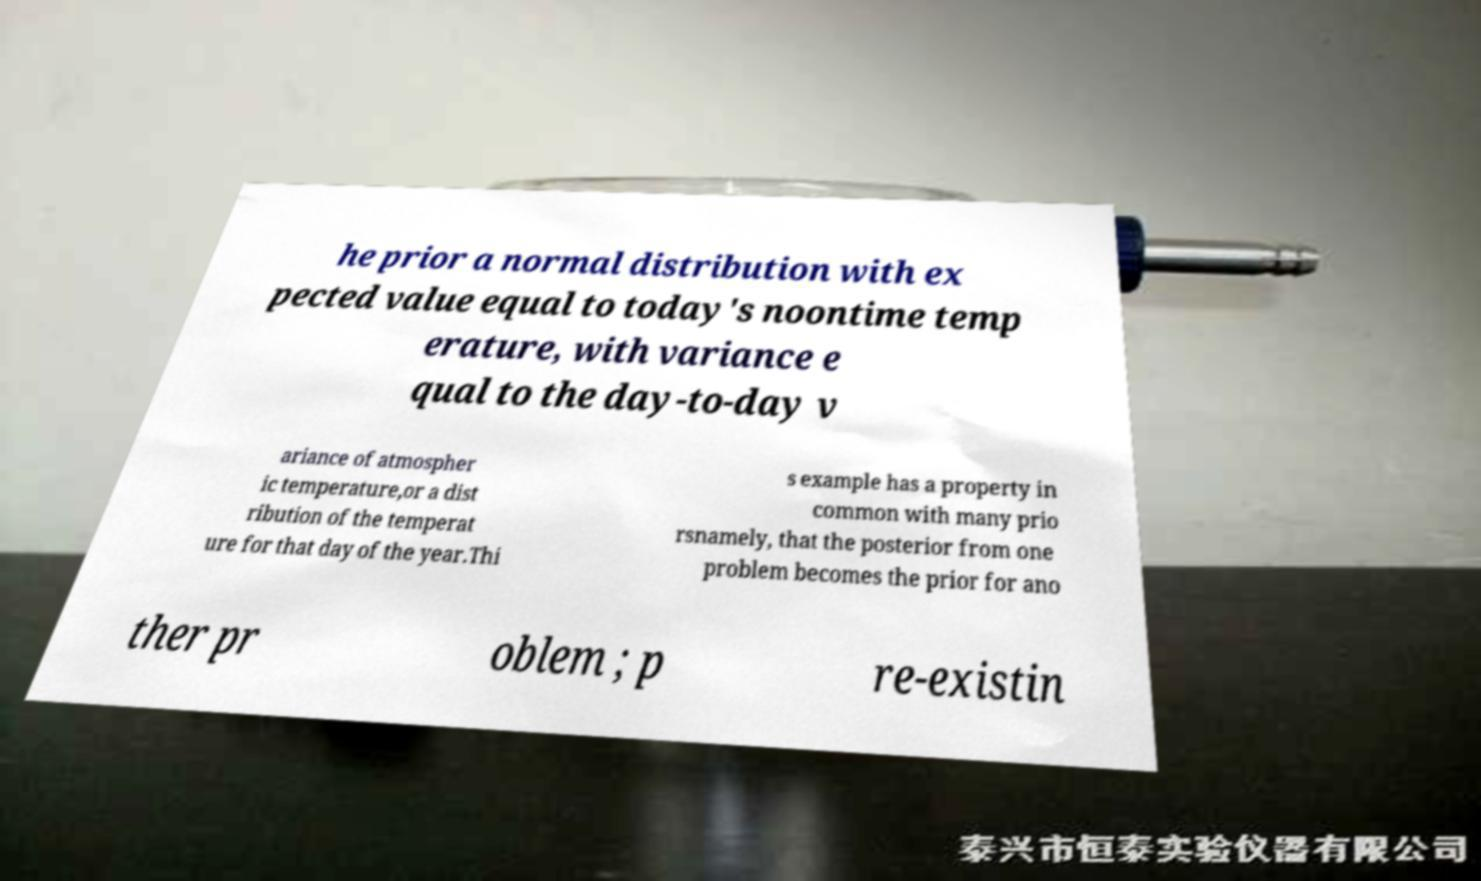What messages or text are displayed in this image? I need them in a readable, typed format. he prior a normal distribution with ex pected value equal to today's noontime temp erature, with variance e qual to the day-to-day v ariance of atmospher ic temperature,or a dist ribution of the temperat ure for that day of the year.Thi s example has a property in common with many prio rsnamely, that the posterior from one problem becomes the prior for ano ther pr oblem ; p re-existin 